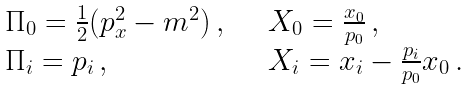<formula> <loc_0><loc_0><loc_500><loc_500>\begin{array} { l l } \Pi _ { 0 } = \frac { 1 } { 2 } ( p _ { x } ^ { 2 } - m ^ { 2 } ) \, , \quad & X _ { 0 } = \frac { x _ { 0 } } { p _ { 0 } } \, , \\ \Pi _ { i } = p _ { i } \, , \quad & X _ { i } = x _ { i } - \frac { p _ { i } } { p _ { 0 } } x _ { 0 } \, . \end{array}</formula> 